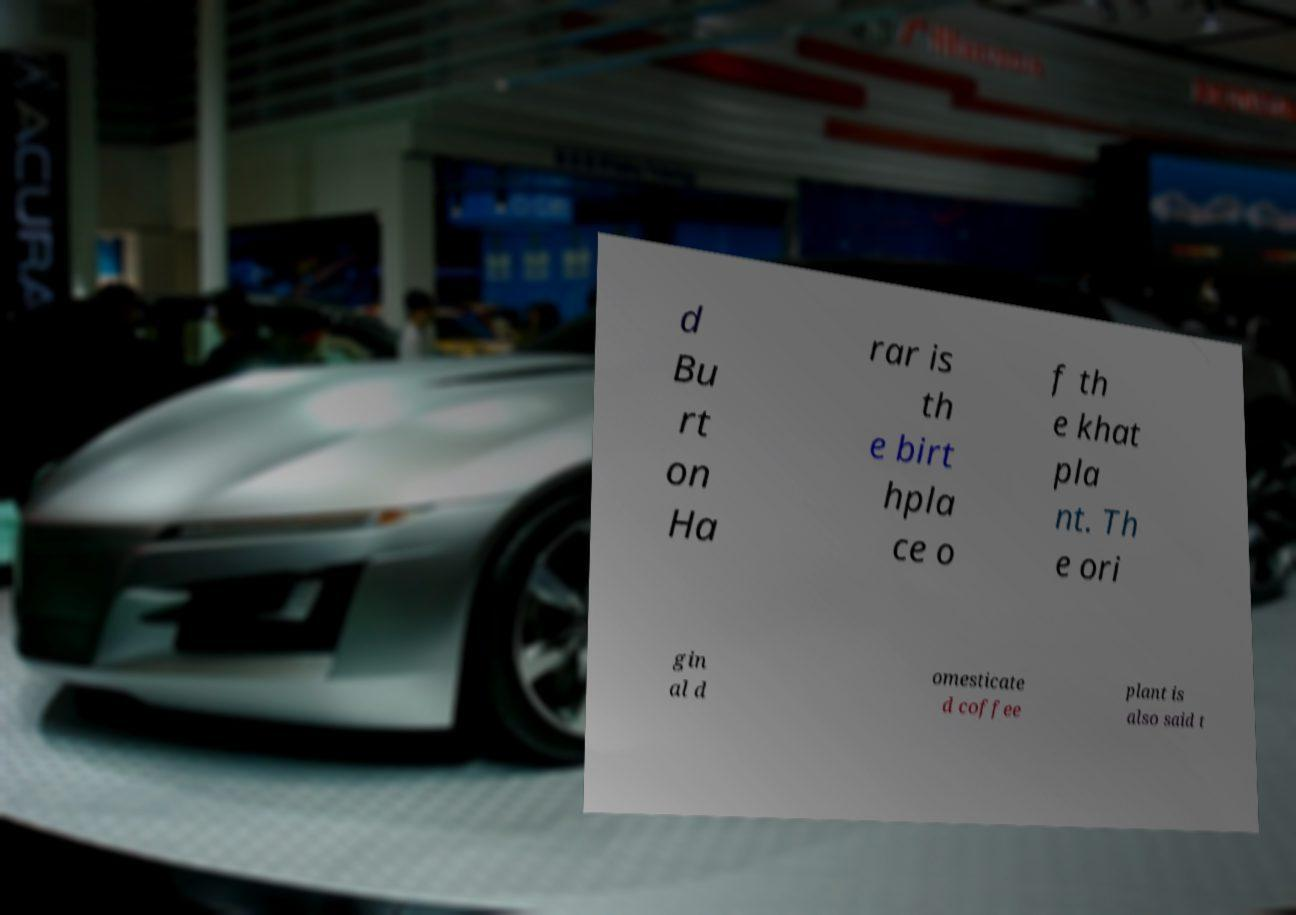Could you assist in decoding the text presented in this image and type it out clearly? d Bu rt on Ha rar is th e birt hpla ce o f th e khat pla nt. Th e ori gin al d omesticate d coffee plant is also said t 